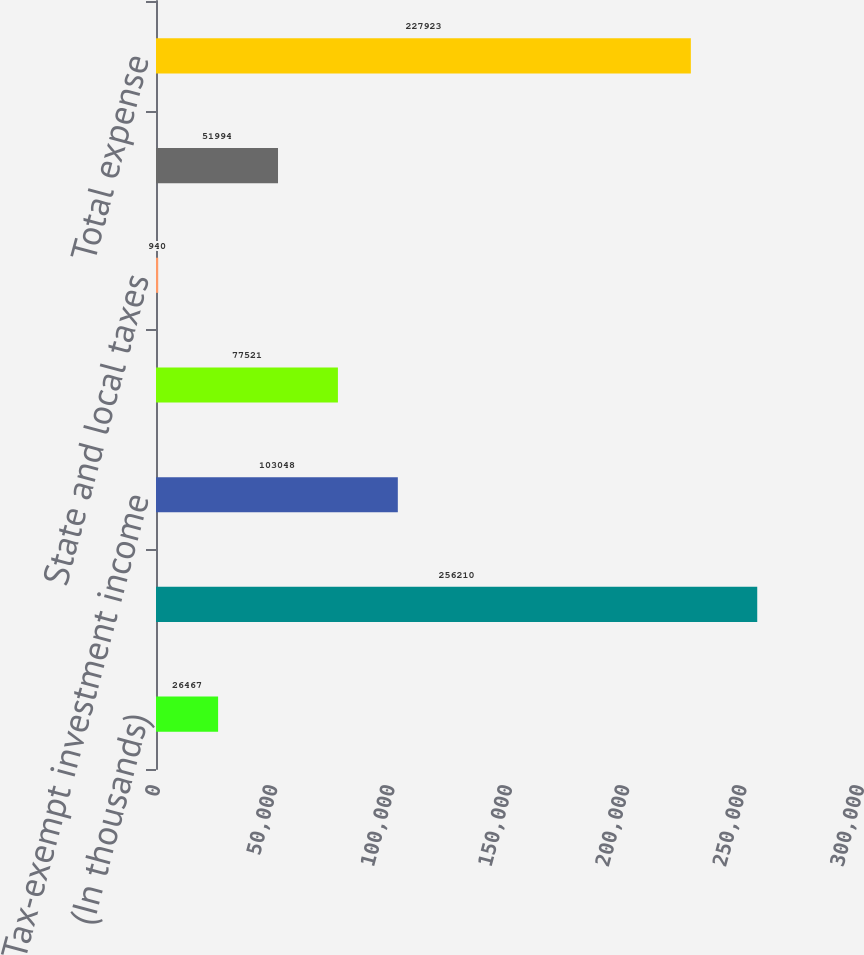Convert chart. <chart><loc_0><loc_0><loc_500><loc_500><bar_chart><fcel>(In thousands)<fcel>Computed expected tax expense<fcel>Tax-exempt investment income<fcel>Impact of foreign tax rates<fcel>State and local taxes<fcel>Other net<fcel>Total expense<nl><fcel>26467<fcel>256210<fcel>103048<fcel>77521<fcel>940<fcel>51994<fcel>227923<nl></chart> 